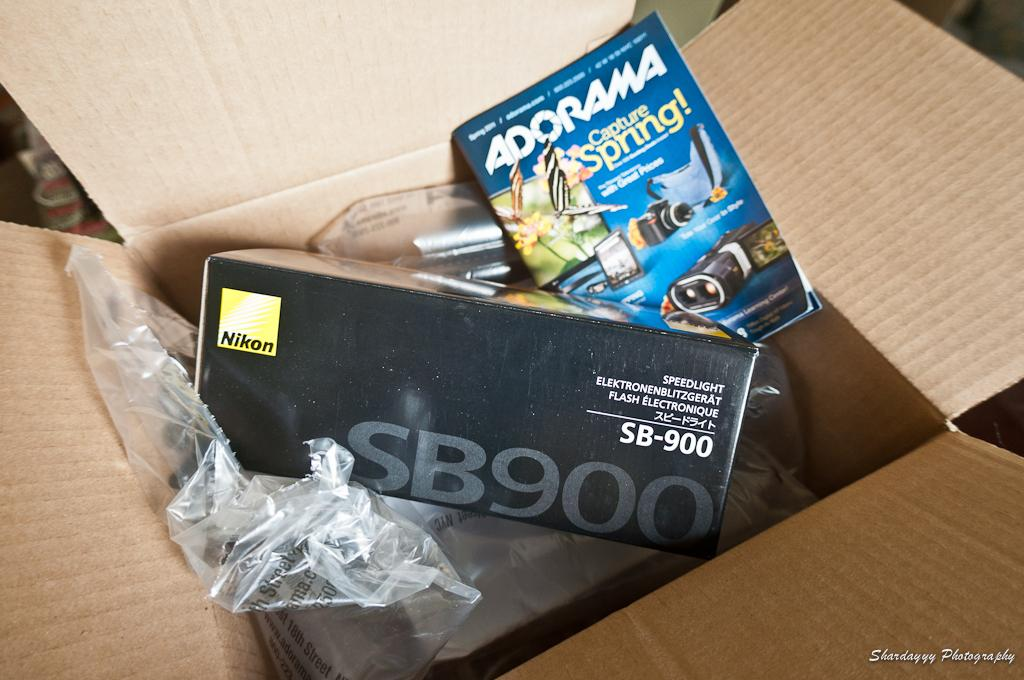Provide a one-sentence caption for the provided image. A Nikon brand product is sitting inside of a cardboard box. 